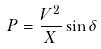Convert formula to latex. <formula><loc_0><loc_0><loc_500><loc_500>P = \frac { V ^ { 2 } } { X } \sin \delta</formula> 